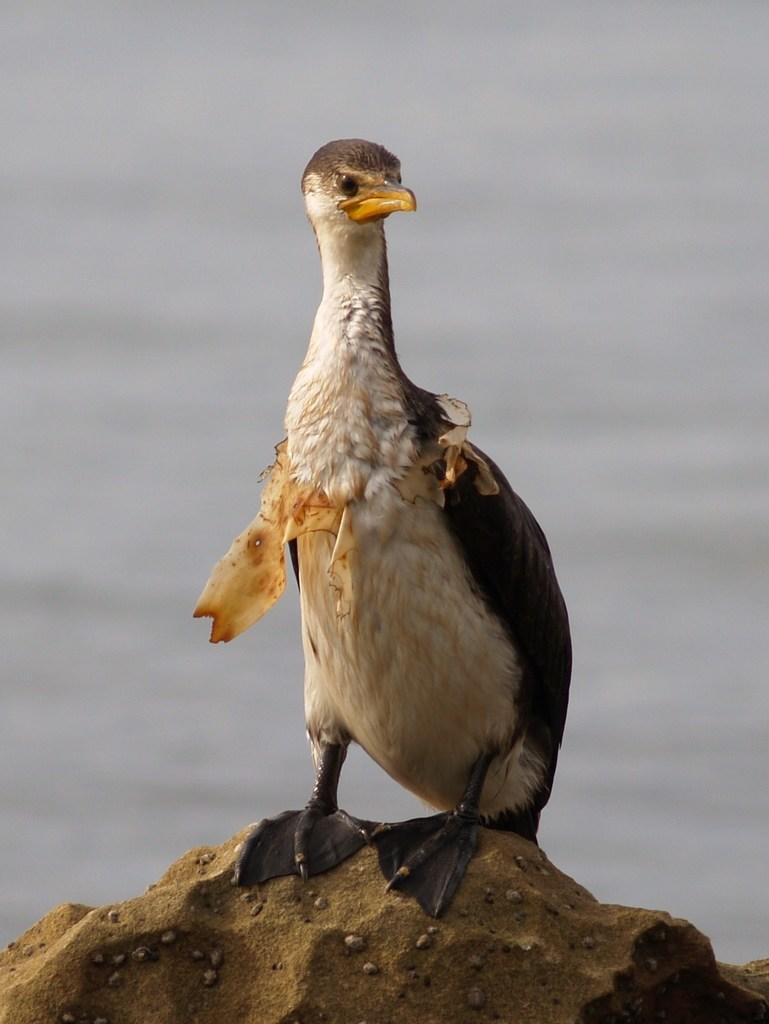What type of animal is present in the image? There is a bird in the image. What is the bird standing on? The bird is standing on a stone. Can you describe the background of the image? The background of the image is blurry. What is the bird's digestion process like in the image? There is no information about the bird's digestion process in the image. What does the bird believe in the image? There is no information about the bird's beliefs in the image. 